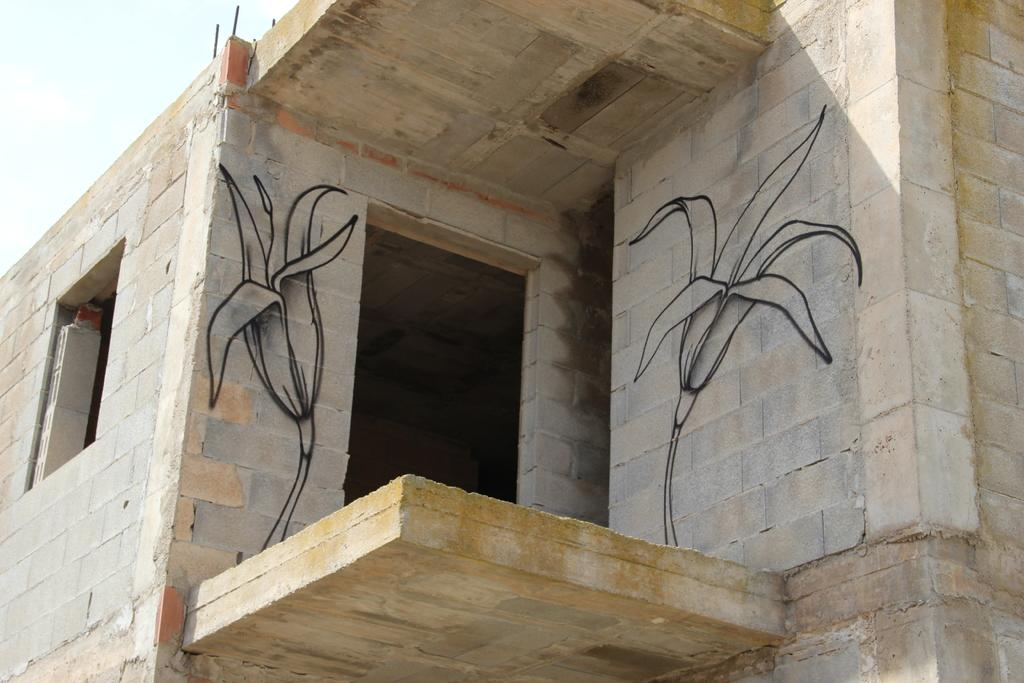What type of structure is present in the image? There is a building in the image. What can be seen in the background of the image? The sky is visible in the background of the image. How many bags are being carried by the trail in the image? There is no trail or bags present in the image; it only features a building and the sky. 